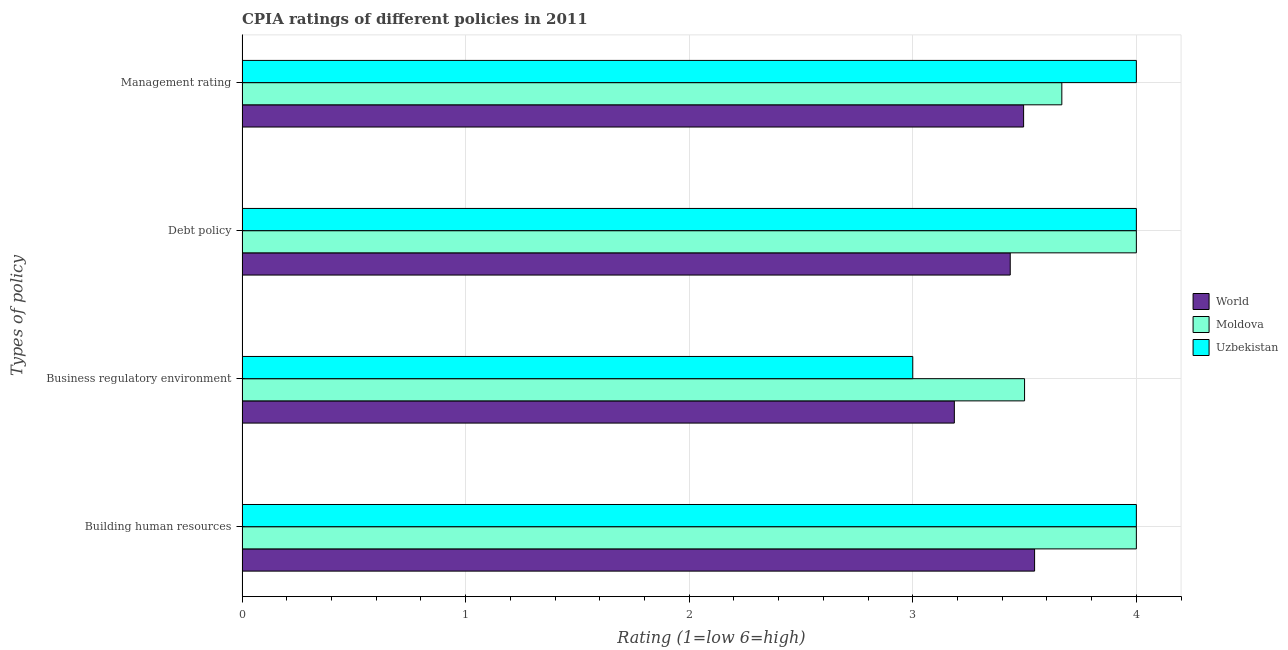How many groups of bars are there?
Your answer should be very brief. 4. Are the number of bars per tick equal to the number of legend labels?
Your response must be concise. Yes. Are the number of bars on each tick of the Y-axis equal?
Ensure brevity in your answer.  Yes. What is the label of the 2nd group of bars from the top?
Provide a short and direct response. Debt policy. What is the cpia rating of debt policy in Uzbekistan?
Make the answer very short. 4. Across all countries, what is the maximum cpia rating of building human resources?
Offer a very short reply. 4. Across all countries, what is the minimum cpia rating of building human resources?
Offer a very short reply. 3.54. In which country was the cpia rating of debt policy maximum?
Your answer should be compact. Moldova. What is the total cpia rating of debt policy in the graph?
Your answer should be very brief. 11.44. What is the difference between the cpia rating of debt policy in Moldova and that in Uzbekistan?
Provide a short and direct response. 0. What is the difference between the cpia rating of business regulatory environment in World and the cpia rating of management in Moldova?
Offer a terse response. -0.48. What is the average cpia rating of building human resources per country?
Your answer should be compact. 3.85. What is the ratio of the cpia rating of building human resources in Moldova to that in Uzbekistan?
Ensure brevity in your answer.  1. Is the cpia rating of debt policy in Uzbekistan less than that in World?
Make the answer very short. No. Is the difference between the cpia rating of management in World and Moldova greater than the difference between the cpia rating of building human resources in World and Moldova?
Ensure brevity in your answer.  Yes. What is the difference between the highest and the second highest cpia rating of business regulatory environment?
Your answer should be compact. 0.31. What is the difference between the highest and the lowest cpia rating of debt policy?
Offer a terse response. 0.56. In how many countries, is the cpia rating of management greater than the average cpia rating of management taken over all countries?
Your response must be concise. 1. Is it the case that in every country, the sum of the cpia rating of management and cpia rating of business regulatory environment is greater than the sum of cpia rating of building human resources and cpia rating of debt policy?
Your answer should be compact. No. What does the 1st bar from the top in Management rating represents?
Your answer should be compact. Uzbekistan. What does the 3rd bar from the bottom in Building human resources represents?
Offer a very short reply. Uzbekistan. Is it the case that in every country, the sum of the cpia rating of building human resources and cpia rating of business regulatory environment is greater than the cpia rating of debt policy?
Your answer should be very brief. Yes. What is the difference between two consecutive major ticks on the X-axis?
Your answer should be very brief. 1. Does the graph contain any zero values?
Your answer should be very brief. No. Does the graph contain grids?
Offer a very short reply. Yes. Where does the legend appear in the graph?
Keep it short and to the point. Center right. How are the legend labels stacked?
Provide a succinct answer. Vertical. What is the title of the graph?
Provide a short and direct response. CPIA ratings of different policies in 2011. Does "Mauritius" appear as one of the legend labels in the graph?
Ensure brevity in your answer.  No. What is the label or title of the X-axis?
Provide a short and direct response. Rating (1=low 6=high). What is the label or title of the Y-axis?
Your response must be concise. Types of policy. What is the Rating (1=low 6=high) of World in Building human resources?
Your answer should be compact. 3.54. What is the Rating (1=low 6=high) in World in Business regulatory environment?
Provide a short and direct response. 3.19. What is the Rating (1=low 6=high) in Moldova in Business regulatory environment?
Give a very brief answer. 3.5. What is the Rating (1=low 6=high) of Uzbekistan in Business regulatory environment?
Your answer should be very brief. 3. What is the Rating (1=low 6=high) of World in Debt policy?
Your answer should be compact. 3.44. What is the Rating (1=low 6=high) in Moldova in Debt policy?
Give a very brief answer. 4. What is the Rating (1=low 6=high) of World in Management rating?
Give a very brief answer. 3.5. What is the Rating (1=low 6=high) in Moldova in Management rating?
Keep it short and to the point. 3.67. What is the Rating (1=low 6=high) in Uzbekistan in Management rating?
Your answer should be very brief. 4. Across all Types of policy, what is the maximum Rating (1=low 6=high) in World?
Ensure brevity in your answer.  3.54. Across all Types of policy, what is the maximum Rating (1=low 6=high) in Moldova?
Offer a very short reply. 4. Across all Types of policy, what is the minimum Rating (1=low 6=high) in World?
Your answer should be compact. 3.19. Across all Types of policy, what is the minimum Rating (1=low 6=high) in Uzbekistan?
Offer a very short reply. 3. What is the total Rating (1=low 6=high) of World in the graph?
Your answer should be compact. 13.66. What is the total Rating (1=low 6=high) of Moldova in the graph?
Your response must be concise. 15.17. What is the difference between the Rating (1=low 6=high) of World in Building human resources and that in Business regulatory environment?
Offer a terse response. 0.36. What is the difference between the Rating (1=low 6=high) in World in Building human resources and that in Debt policy?
Ensure brevity in your answer.  0.11. What is the difference between the Rating (1=low 6=high) in Moldova in Building human resources and that in Debt policy?
Ensure brevity in your answer.  0. What is the difference between the Rating (1=low 6=high) of Uzbekistan in Building human resources and that in Debt policy?
Provide a succinct answer. 0. What is the difference between the Rating (1=low 6=high) of World in Building human resources and that in Management rating?
Provide a succinct answer. 0.05. What is the difference between the Rating (1=low 6=high) of Uzbekistan in Building human resources and that in Management rating?
Your response must be concise. 0. What is the difference between the Rating (1=low 6=high) of World in Business regulatory environment and that in Debt policy?
Your answer should be very brief. -0.25. What is the difference between the Rating (1=low 6=high) in Uzbekistan in Business regulatory environment and that in Debt policy?
Ensure brevity in your answer.  -1. What is the difference between the Rating (1=low 6=high) of World in Business regulatory environment and that in Management rating?
Give a very brief answer. -0.31. What is the difference between the Rating (1=low 6=high) of Moldova in Business regulatory environment and that in Management rating?
Your answer should be very brief. -0.17. What is the difference between the Rating (1=low 6=high) in World in Debt policy and that in Management rating?
Make the answer very short. -0.06. What is the difference between the Rating (1=low 6=high) of Uzbekistan in Debt policy and that in Management rating?
Your answer should be compact. 0. What is the difference between the Rating (1=low 6=high) of World in Building human resources and the Rating (1=low 6=high) of Moldova in Business regulatory environment?
Your response must be concise. 0.04. What is the difference between the Rating (1=low 6=high) of World in Building human resources and the Rating (1=low 6=high) of Uzbekistan in Business regulatory environment?
Your answer should be very brief. 0.54. What is the difference between the Rating (1=low 6=high) in Moldova in Building human resources and the Rating (1=low 6=high) in Uzbekistan in Business regulatory environment?
Your answer should be very brief. 1. What is the difference between the Rating (1=low 6=high) of World in Building human resources and the Rating (1=low 6=high) of Moldova in Debt policy?
Provide a short and direct response. -0.46. What is the difference between the Rating (1=low 6=high) in World in Building human resources and the Rating (1=low 6=high) in Uzbekistan in Debt policy?
Provide a short and direct response. -0.46. What is the difference between the Rating (1=low 6=high) in World in Building human resources and the Rating (1=low 6=high) in Moldova in Management rating?
Ensure brevity in your answer.  -0.12. What is the difference between the Rating (1=low 6=high) in World in Building human resources and the Rating (1=low 6=high) in Uzbekistan in Management rating?
Offer a very short reply. -0.46. What is the difference between the Rating (1=low 6=high) of Moldova in Building human resources and the Rating (1=low 6=high) of Uzbekistan in Management rating?
Give a very brief answer. 0. What is the difference between the Rating (1=low 6=high) in World in Business regulatory environment and the Rating (1=low 6=high) in Moldova in Debt policy?
Offer a very short reply. -0.81. What is the difference between the Rating (1=low 6=high) of World in Business regulatory environment and the Rating (1=low 6=high) of Uzbekistan in Debt policy?
Make the answer very short. -0.81. What is the difference between the Rating (1=low 6=high) of World in Business regulatory environment and the Rating (1=low 6=high) of Moldova in Management rating?
Your answer should be compact. -0.48. What is the difference between the Rating (1=low 6=high) in World in Business regulatory environment and the Rating (1=low 6=high) in Uzbekistan in Management rating?
Ensure brevity in your answer.  -0.81. What is the difference between the Rating (1=low 6=high) in Moldova in Business regulatory environment and the Rating (1=low 6=high) in Uzbekistan in Management rating?
Give a very brief answer. -0.5. What is the difference between the Rating (1=low 6=high) of World in Debt policy and the Rating (1=low 6=high) of Moldova in Management rating?
Offer a very short reply. -0.23. What is the difference between the Rating (1=low 6=high) of World in Debt policy and the Rating (1=low 6=high) of Uzbekistan in Management rating?
Offer a very short reply. -0.56. What is the difference between the Rating (1=low 6=high) in Moldova in Debt policy and the Rating (1=low 6=high) in Uzbekistan in Management rating?
Keep it short and to the point. 0. What is the average Rating (1=low 6=high) of World per Types of policy?
Keep it short and to the point. 3.42. What is the average Rating (1=low 6=high) in Moldova per Types of policy?
Provide a succinct answer. 3.79. What is the average Rating (1=low 6=high) in Uzbekistan per Types of policy?
Make the answer very short. 3.75. What is the difference between the Rating (1=low 6=high) in World and Rating (1=low 6=high) in Moldova in Building human resources?
Offer a terse response. -0.46. What is the difference between the Rating (1=low 6=high) of World and Rating (1=low 6=high) of Uzbekistan in Building human resources?
Make the answer very short. -0.46. What is the difference between the Rating (1=low 6=high) in World and Rating (1=low 6=high) in Moldova in Business regulatory environment?
Your answer should be very brief. -0.31. What is the difference between the Rating (1=low 6=high) of World and Rating (1=low 6=high) of Uzbekistan in Business regulatory environment?
Offer a terse response. 0.19. What is the difference between the Rating (1=low 6=high) of Moldova and Rating (1=low 6=high) of Uzbekistan in Business regulatory environment?
Your answer should be compact. 0.5. What is the difference between the Rating (1=low 6=high) of World and Rating (1=low 6=high) of Moldova in Debt policy?
Your answer should be very brief. -0.56. What is the difference between the Rating (1=low 6=high) in World and Rating (1=low 6=high) in Uzbekistan in Debt policy?
Provide a short and direct response. -0.56. What is the difference between the Rating (1=low 6=high) in Moldova and Rating (1=low 6=high) in Uzbekistan in Debt policy?
Give a very brief answer. 0. What is the difference between the Rating (1=low 6=high) in World and Rating (1=low 6=high) in Moldova in Management rating?
Keep it short and to the point. -0.17. What is the difference between the Rating (1=low 6=high) of World and Rating (1=low 6=high) of Uzbekistan in Management rating?
Provide a short and direct response. -0.5. What is the ratio of the Rating (1=low 6=high) of World in Building human resources to that in Business regulatory environment?
Provide a succinct answer. 1.11. What is the ratio of the Rating (1=low 6=high) in World in Building human resources to that in Debt policy?
Make the answer very short. 1.03. What is the ratio of the Rating (1=low 6=high) of Moldova in Building human resources to that in Debt policy?
Offer a terse response. 1. What is the ratio of the Rating (1=low 6=high) in Uzbekistan in Building human resources to that in Debt policy?
Your response must be concise. 1. What is the ratio of the Rating (1=low 6=high) in World in Building human resources to that in Management rating?
Your answer should be very brief. 1.01. What is the ratio of the Rating (1=low 6=high) in Uzbekistan in Building human resources to that in Management rating?
Give a very brief answer. 1. What is the ratio of the Rating (1=low 6=high) in World in Business regulatory environment to that in Debt policy?
Provide a succinct answer. 0.93. What is the ratio of the Rating (1=low 6=high) of Moldova in Business regulatory environment to that in Debt policy?
Your response must be concise. 0.88. What is the ratio of the Rating (1=low 6=high) in World in Business regulatory environment to that in Management rating?
Provide a short and direct response. 0.91. What is the ratio of the Rating (1=low 6=high) of Moldova in Business regulatory environment to that in Management rating?
Provide a succinct answer. 0.95. What is the ratio of the Rating (1=low 6=high) in World in Debt policy to that in Management rating?
Your answer should be very brief. 0.98. What is the ratio of the Rating (1=low 6=high) in Moldova in Debt policy to that in Management rating?
Give a very brief answer. 1.09. What is the ratio of the Rating (1=low 6=high) in Uzbekistan in Debt policy to that in Management rating?
Make the answer very short. 1. What is the difference between the highest and the second highest Rating (1=low 6=high) of World?
Make the answer very short. 0.05. What is the difference between the highest and the second highest Rating (1=low 6=high) in Moldova?
Make the answer very short. 0. What is the difference between the highest and the lowest Rating (1=low 6=high) in World?
Offer a very short reply. 0.36. What is the difference between the highest and the lowest Rating (1=low 6=high) in Moldova?
Ensure brevity in your answer.  0.5. 